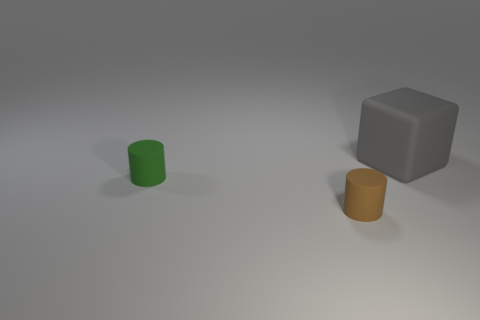Add 1 small cylinders. How many objects exist? 4 Subtract all blocks. How many objects are left? 2 Add 3 large metallic spheres. How many large metallic spheres exist? 3 Subtract 0 gray cylinders. How many objects are left? 3 Subtract all small green matte things. Subtract all matte cylinders. How many objects are left? 0 Add 3 big objects. How many big objects are left? 4 